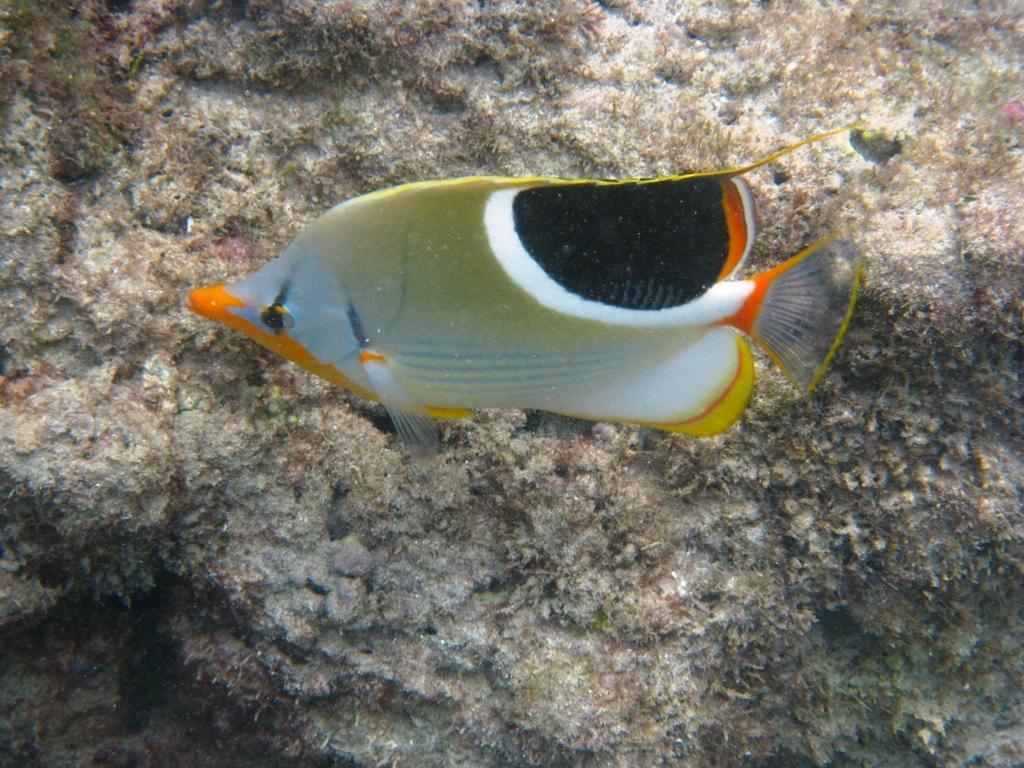In one or two sentences, can you explain what this image depicts? There is a fish under the water in the foreground, it seems like rock in the background area. 